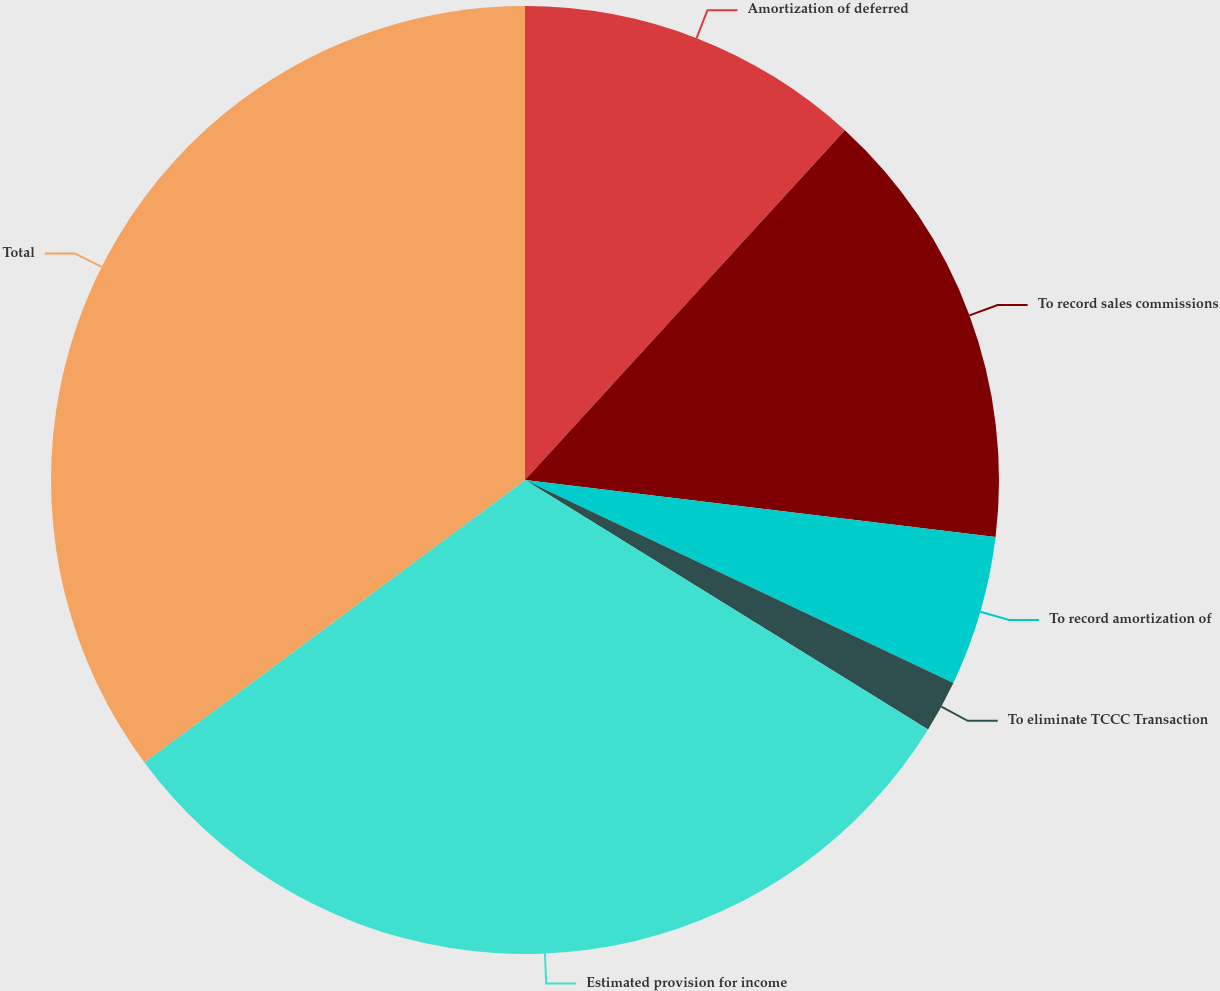Convert chart to OTSL. <chart><loc_0><loc_0><loc_500><loc_500><pie_chart><fcel>Amortization of deferred<fcel>To record sales commissions<fcel>To record amortization of<fcel>To eliminate TCCC Transaction<fcel>Estimated provision for income<fcel>Total<nl><fcel>11.79%<fcel>15.13%<fcel>5.12%<fcel>1.78%<fcel>31.02%<fcel>35.16%<nl></chart> 